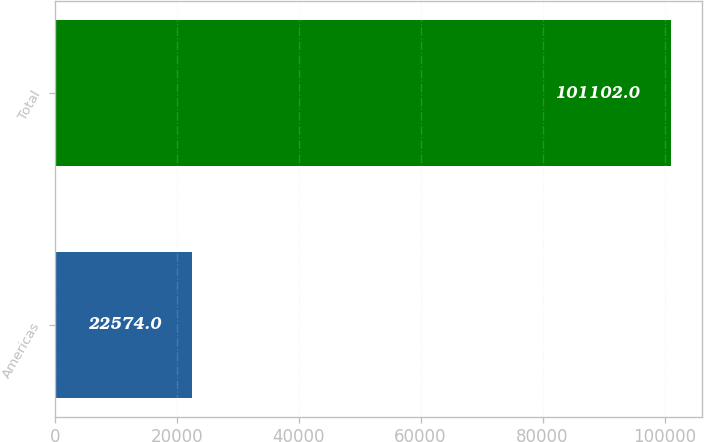<chart> <loc_0><loc_0><loc_500><loc_500><bar_chart><fcel>Americas<fcel>Total<nl><fcel>22574<fcel>101102<nl></chart> 